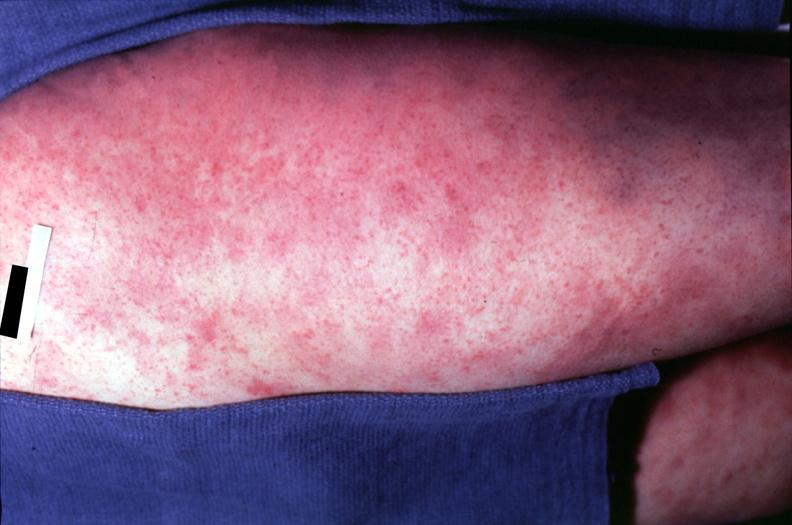what spotted fever, morbilliform rash?
Answer the question using a single word or phrase. Rocky mountain 